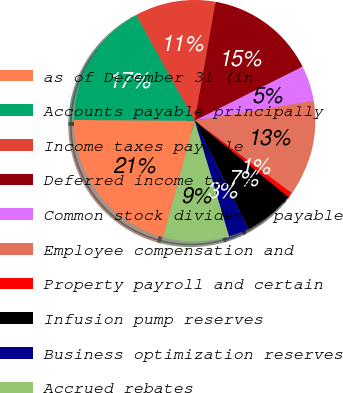Convert chart to OTSL. <chart><loc_0><loc_0><loc_500><loc_500><pie_chart><fcel>as of December 31 (in<fcel>Accounts payable principally<fcel>Income taxes payable<fcel>Deferred income taxes<fcel>Common stock dividends payable<fcel>Employee compensation and<fcel>Property payroll and certain<fcel>Infusion pump reserves<fcel>Business optimization reserves<fcel>Accrued rebates<nl><fcel>20.9%<fcel>16.87%<fcel>10.81%<fcel>14.85%<fcel>4.75%<fcel>12.83%<fcel>0.71%<fcel>6.77%<fcel>2.73%<fcel>8.79%<nl></chart> 